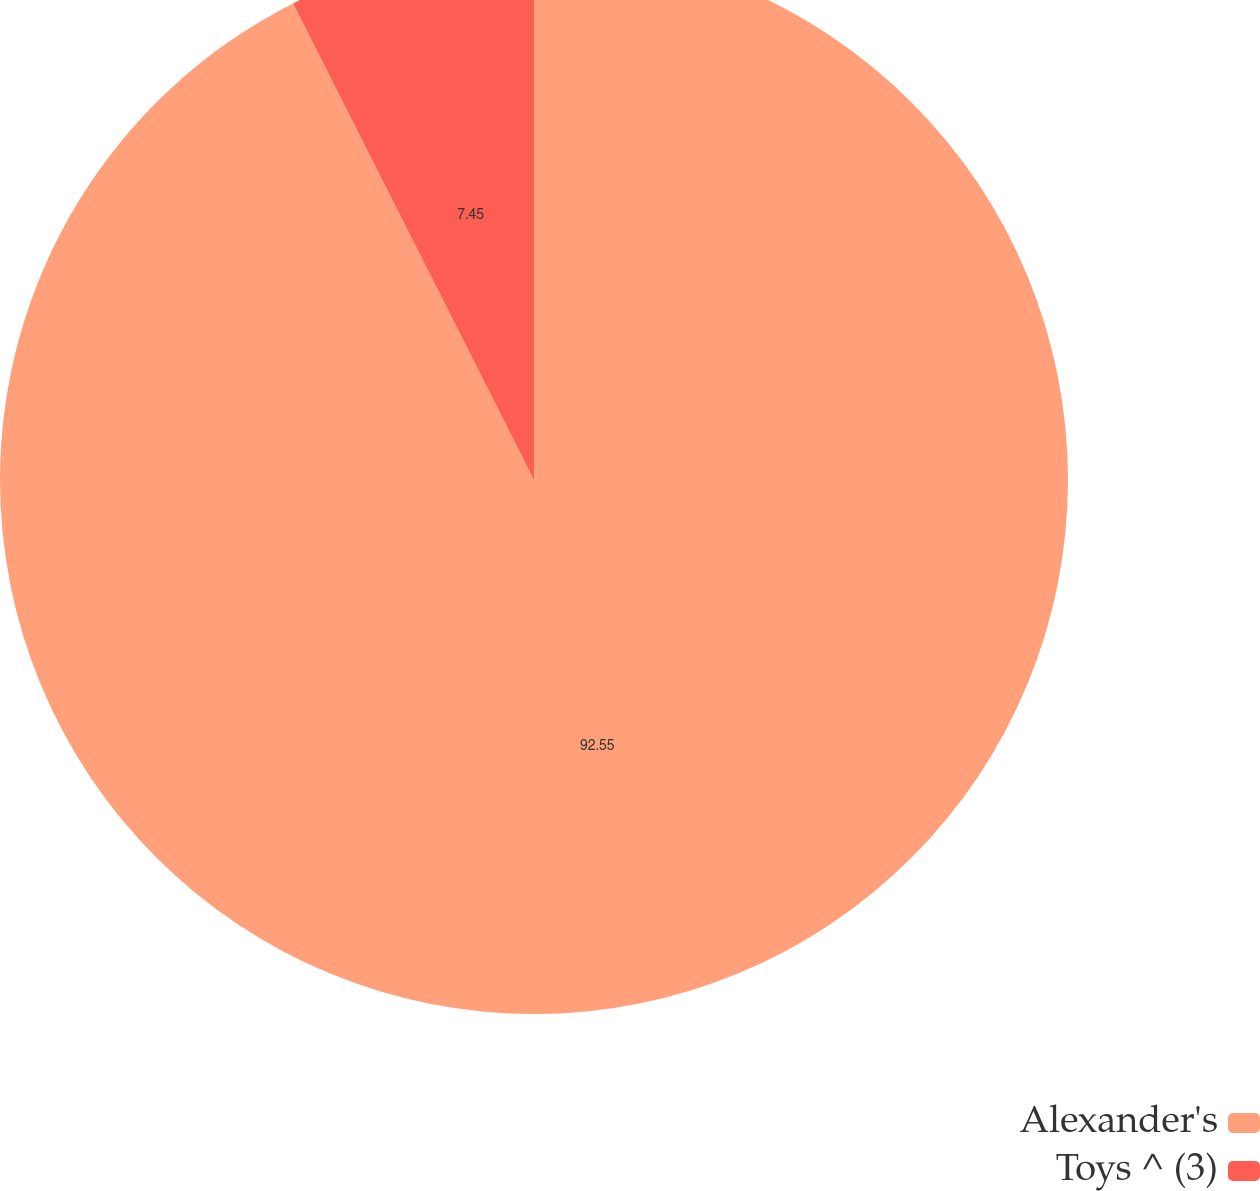Convert chart. <chart><loc_0><loc_0><loc_500><loc_500><pie_chart><fcel>Alexander's<fcel>Toys ^ (3)<nl><fcel>92.55%<fcel>7.45%<nl></chart> 